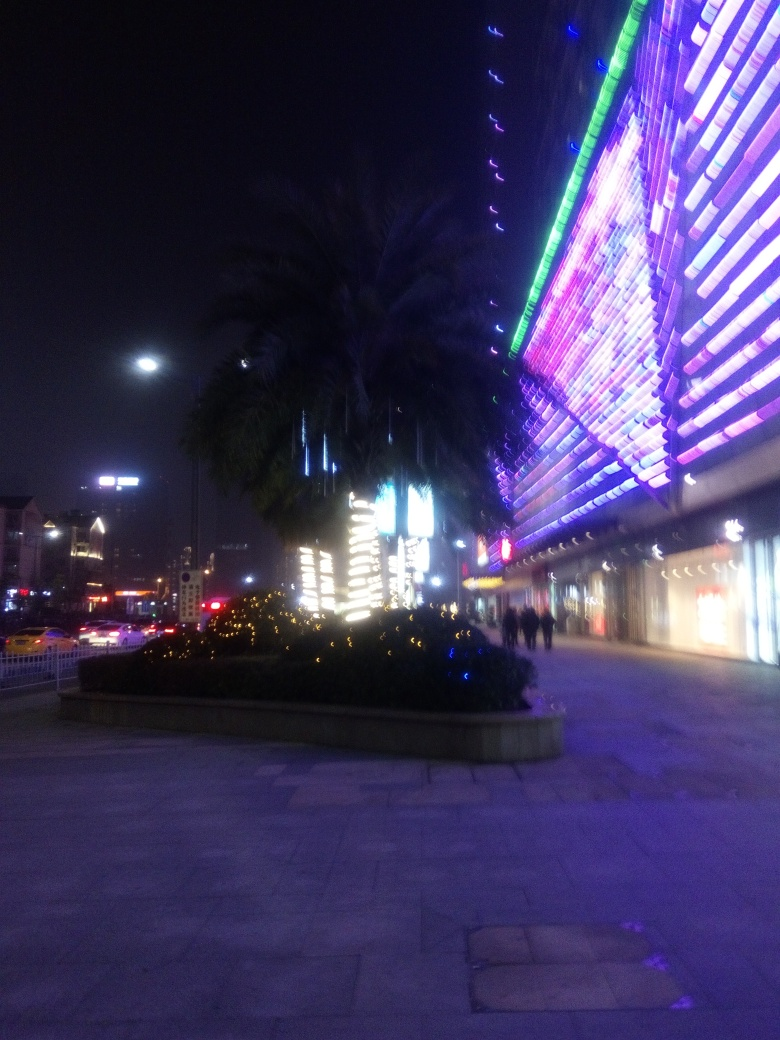What time of day does this image seem to depict, based on the lighting and activities visible? The image appears to be taken during the night. This is indicated by the artificial lighting, the dark sky, and the illuminated street and building lights. The presence of pedestrians suggests it's likely early night when shops and public areas are still active. 